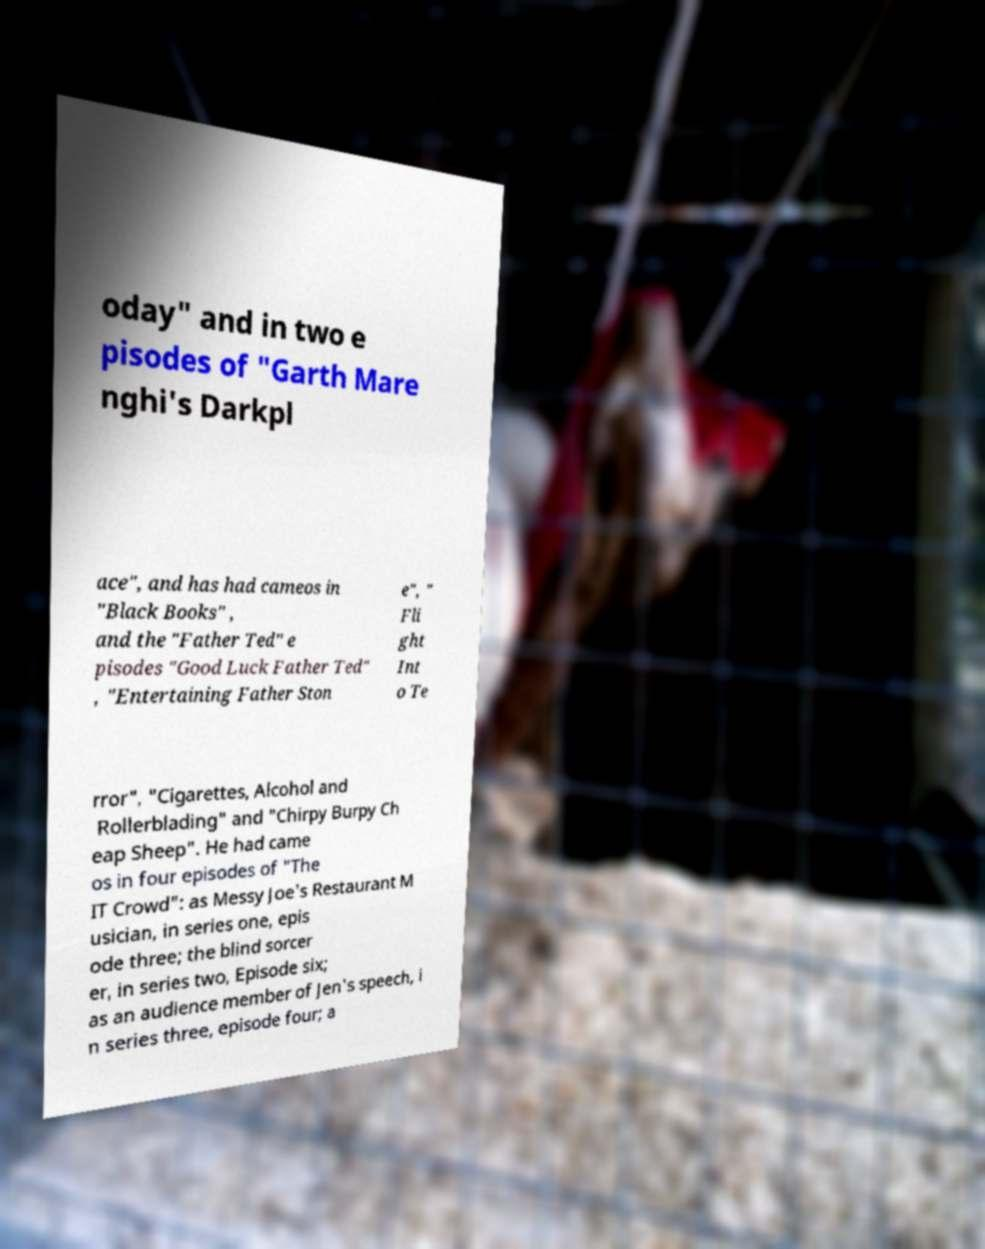I need the written content from this picture converted into text. Can you do that? oday" and in two e pisodes of "Garth Mare nghi's Darkpl ace", and has had cameos in "Black Books" , and the "Father Ted" e pisodes "Good Luck Father Ted" , "Entertaining Father Ston e", " Fli ght Int o Te rror", "Cigarettes, Alcohol and Rollerblading" and "Chirpy Burpy Ch eap Sheep". He had came os in four episodes of "The IT Crowd": as Messy Joe's Restaurant M usician, in series one, epis ode three; the blind sorcer er, in series two, Episode six; as an audience member of Jen's speech, i n series three, episode four; a 